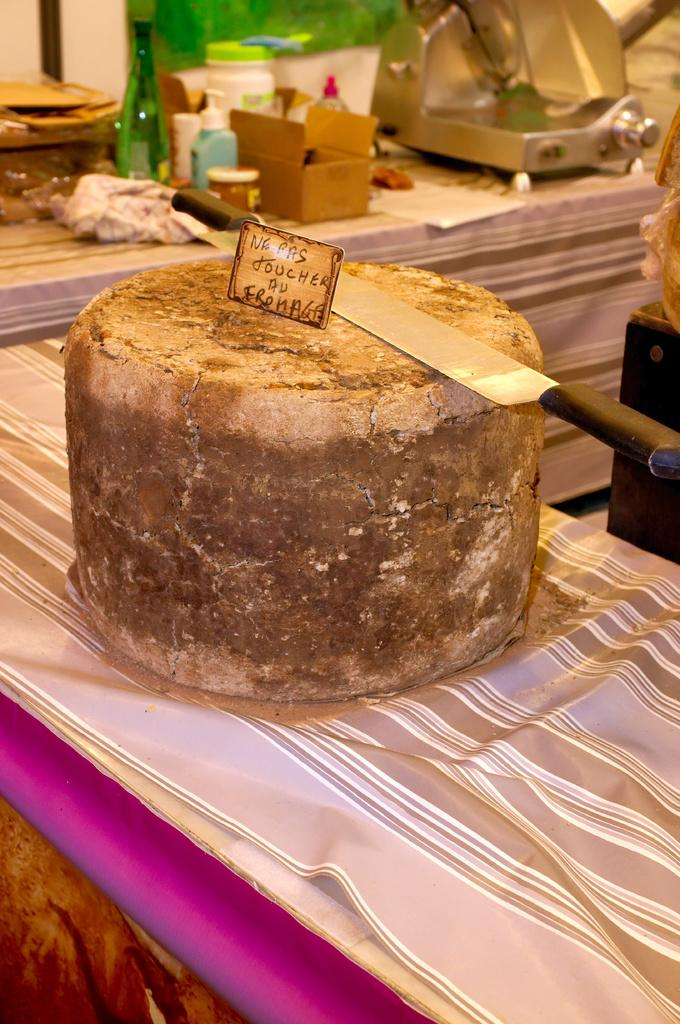What is one of the objects in the image? There is a knife in the image. What is another object in the image? There is a board in the image. Where are the knife and board located? The knife and board are on an object in the image. What other items can be seen in the image? There is a bottle and a container in the image. Are there any other objects visible in the image? Yes, there are other objects visible in the image. What type of glue is being used to attach the ship to the container in the image? There is no ship or glue present in the image. What type of education is being provided in the image? There is no indication of education or any educational materials in the image. 